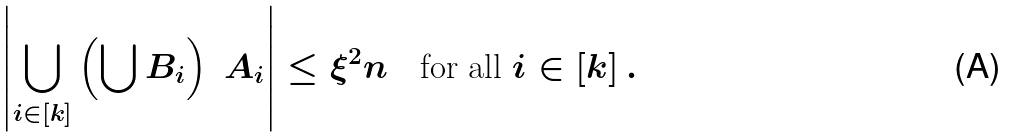Convert formula to latex. <formula><loc_0><loc_0><loc_500><loc_500>\left | \bigcup _ { i \in [ k ] } \left ( \bigcup B _ { i } \right ) \ A _ { i } \right | \leq \xi ^ { 2 } n \quad \text {for all $i\in[k]$} \, .</formula> 